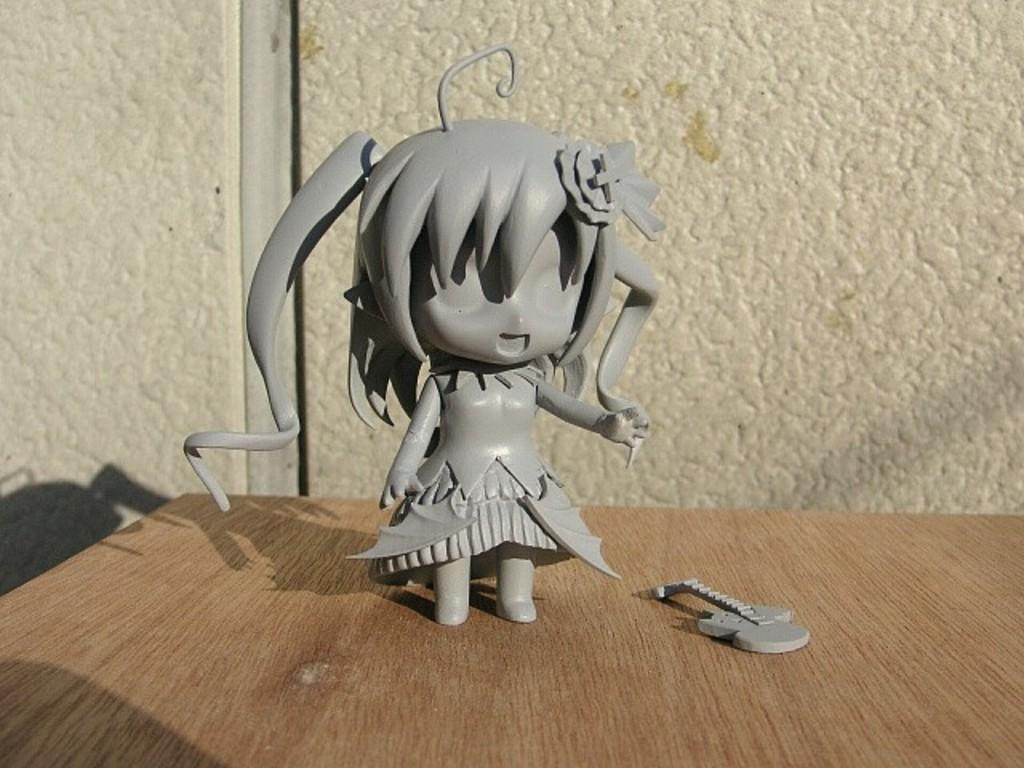What objects are on the table in the image? There are toys on a table in the image. Where is the table located in relation to the wall? The table is in front of a wall in the image. What type of regret can be seen on the toys in the image? There is no indication of regret in the image, as regret is an emotion and not a characteristic of toys. How many jellyfish are present on the table in the image? There are no jellyfish present on the table in the image. 